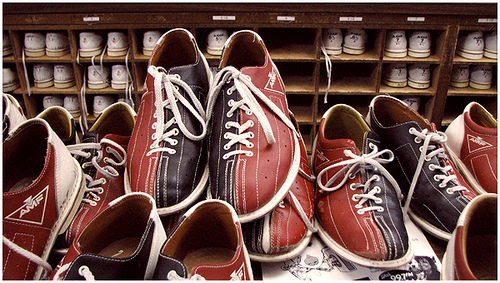<image>
Can you confirm if the cubbyhole is to the left of the nametag? No. The cubbyhole is not to the left of the nametag. From this viewpoint, they have a different horizontal relationship. 